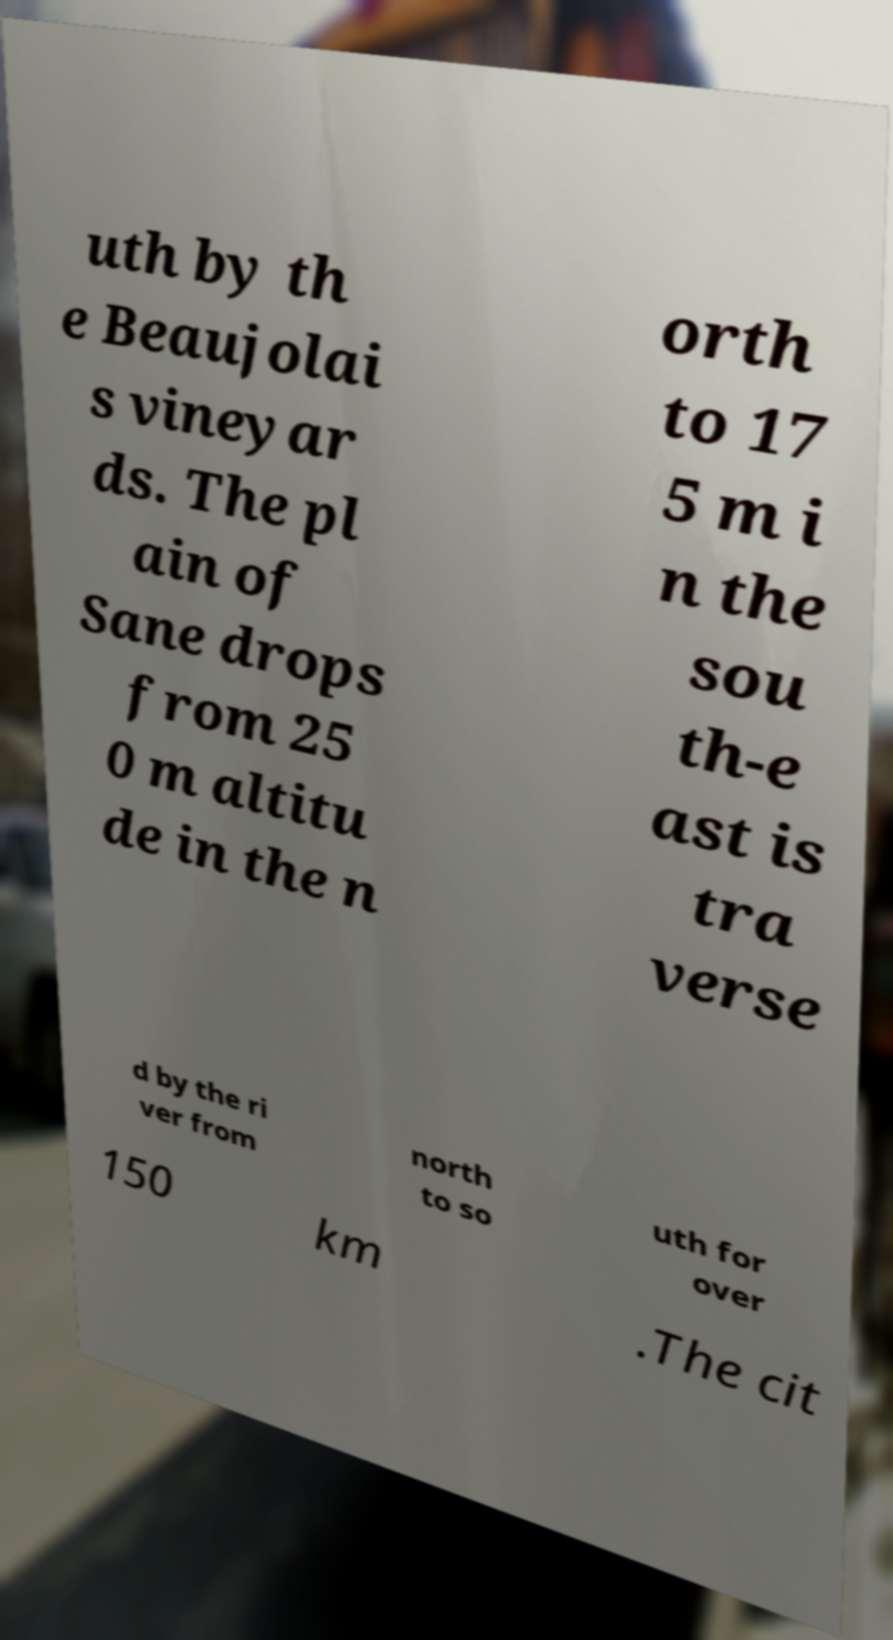Could you assist in decoding the text presented in this image and type it out clearly? uth by th e Beaujolai s vineyar ds. The pl ain of Sane drops from 25 0 m altitu de in the n orth to 17 5 m i n the sou th-e ast is tra verse d by the ri ver from north to so uth for over 150 km .The cit 